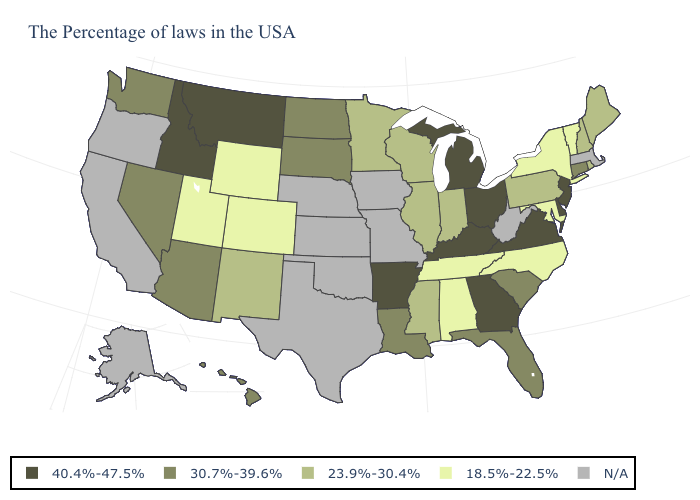Does the first symbol in the legend represent the smallest category?
Keep it brief. No. Which states have the lowest value in the USA?
Keep it brief. Vermont, New York, Maryland, North Carolina, Alabama, Tennessee, Wyoming, Colorado, Utah. Name the states that have a value in the range 23.9%-30.4%?
Concise answer only. Maine, Rhode Island, New Hampshire, Pennsylvania, Indiana, Wisconsin, Illinois, Mississippi, Minnesota, New Mexico. Among the states that border Utah , does Idaho have the highest value?
Quick response, please. Yes. What is the value of Missouri?
Be succinct. N/A. Name the states that have a value in the range N/A?
Give a very brief answer. Massachusetts, West Virginia, Missouri, Iowa, Kansas, Nebraska, Oklahoma, Texas, California, Oregon, Alaska. Among the states that border North Dakota , does South Dakota have the lowest value?
Give a very brief answer. No. What is the highest value in states that border North Carolina?
Short answer required. 40.4%-47.5%. Does Ohio have the highest value in the USA?
Keep it brief. Yes. What is the lowest value in the USA?
Be succinct. 18.5%-22.5%. Name the states that have a value in the range 40.4%-47.5%?
Answer briefly. New Jersey, Delaware, Virginia, Ohio, Georgia, Michigan, Kentucky, Arkansas, Montana, Idaho. Among the states that border Michigan , does Ohio have the lowest value?
Answer briefly. No. Which states have the lowest value in the USA?
Concise answer only. Vermont, New York, Maryland, North Carolina, Alabama, Tennessee, Wyoming, Colorado, Utah. 